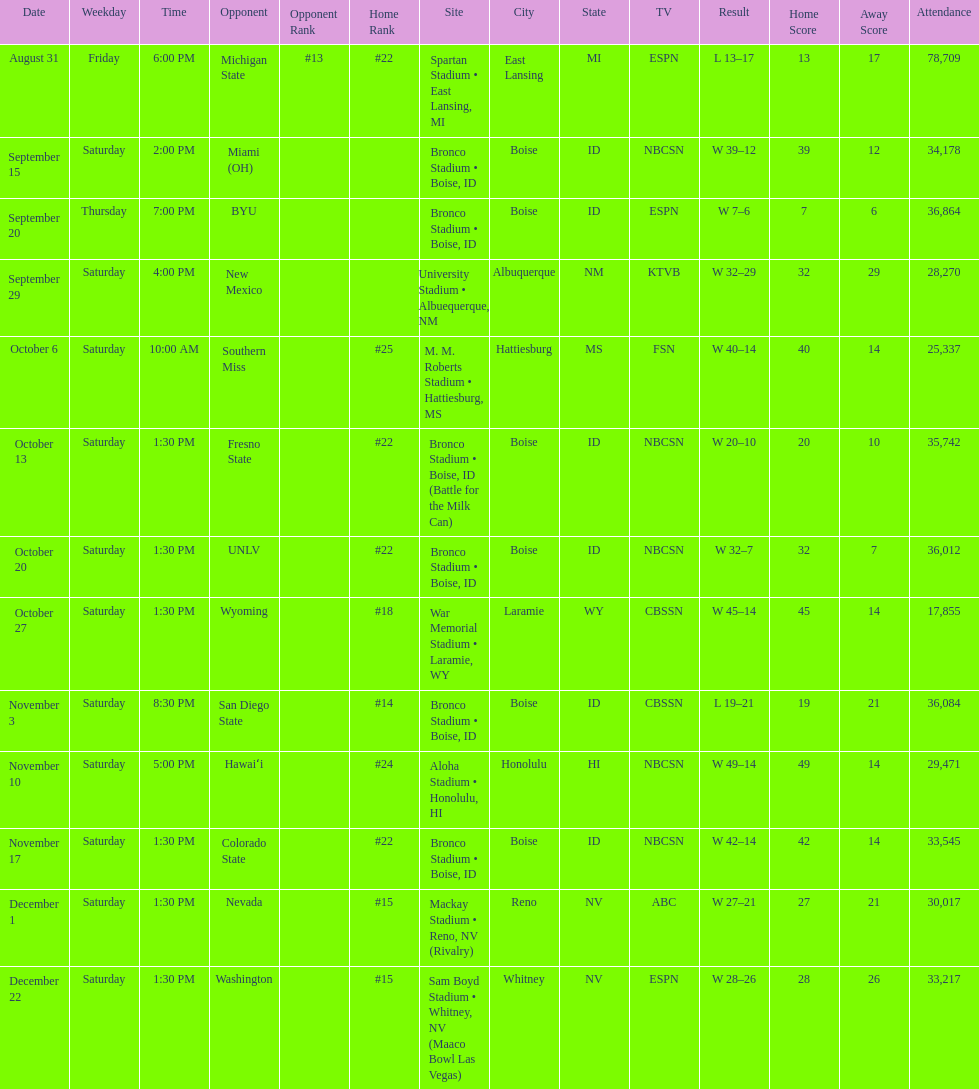What is the score difference for the game against michigan state? 4. 